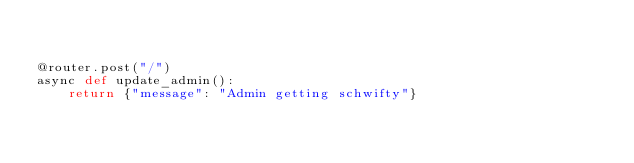<code> <loc_0><loc_0><loc_500><loc_500><_Python_>

@router.post("/")
async def update_admin():
    return {"message": "Admin getting schwifty"}
</code> 